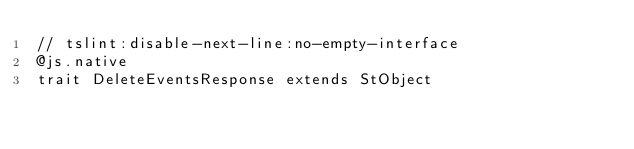Convert code to text. <code><loc_0><loc_0><loc_500><loc_500><_Scala_>// tslint:disable-next-line:no-empty-interface
@js.native
trait DeleteEventsResponse extends StObject
</code> 